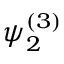Convert formula to latex. <formula><loc_0><loc_0><loc_500><loc_500>\psi _ { 2 } ^ { ( 3 ) }</formula> 